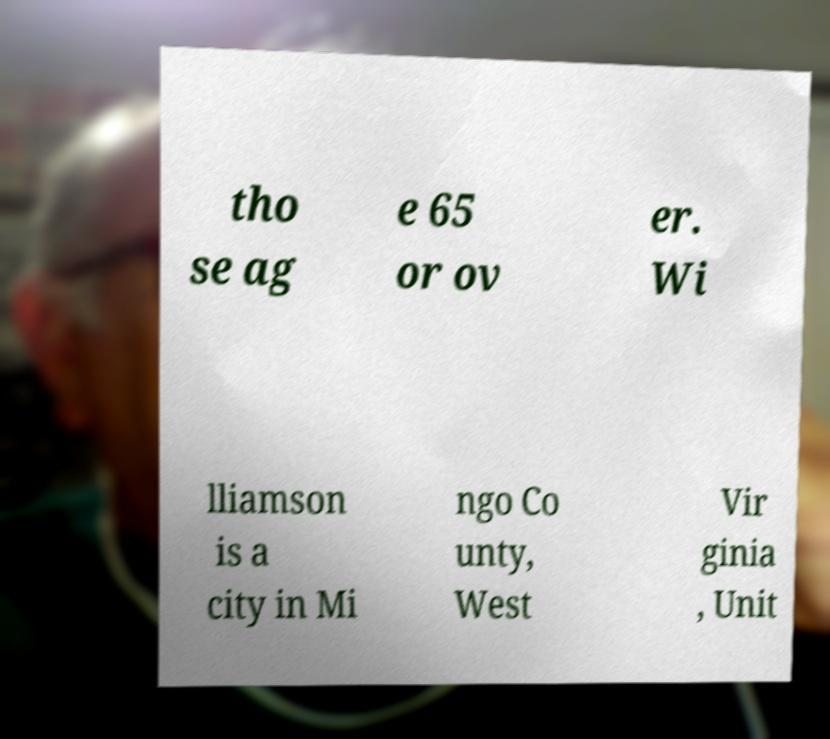For documentation purposes, I need the text within this image transcribed. Could you provide that? tho se ag e 65 or ov er. Wi lliamson is a city in Mi ngo Co unty, West Vir ginia , Unit 